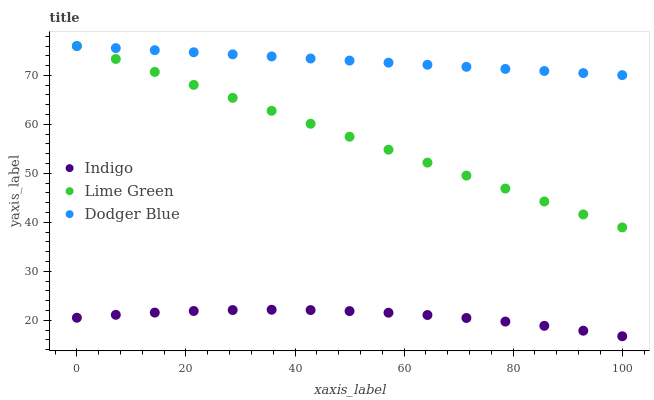Does Indigo have the minimum area under the curve?
Answer yes or no. Yes. Does Dodger Blue have the maximum area under the curve?
Answer yes or no. Yes. Does Dodger Blue have the minimum area under the curve?
Answer yes or no. No. Does Indigo have the maximum area under the curve?
Answer yes or no. No. Is Dodger Blue the smoothest?
Answer yes or no. Yes. Is Indigo the roughest?
Answer yes or no. Yes. Is Indigo the smoothest?
Answer yes or no. No. Is Dodger Blue the roughest?
Answer yes or no. No. Does Indigo have the lowest value?
Answer yes or no. Yes. Does Dodger Blue have the lowest value?
Answer yes or no. No. Does Dodger Blue have the highest value?
Answer yes or no. Yes. Does Indigo have the highest value?
Answer yes or no. No. Is Indigo less than Dodger Blue?
Answer yes or no. Yes. Is Dodger Blue greater than Indigo?
Answer yes or no. Yes. Does Dodger Blue intersect Lime Green?
Answer yes or no. Yes. Is Dodger Blue less than Lime Green?
Answer yes or no. No. Is Dodger Blue greater than Lime Green?
Answer yes or no. No. Does Indigo intersect Dodger Blue?
Answer yes or no. No. 